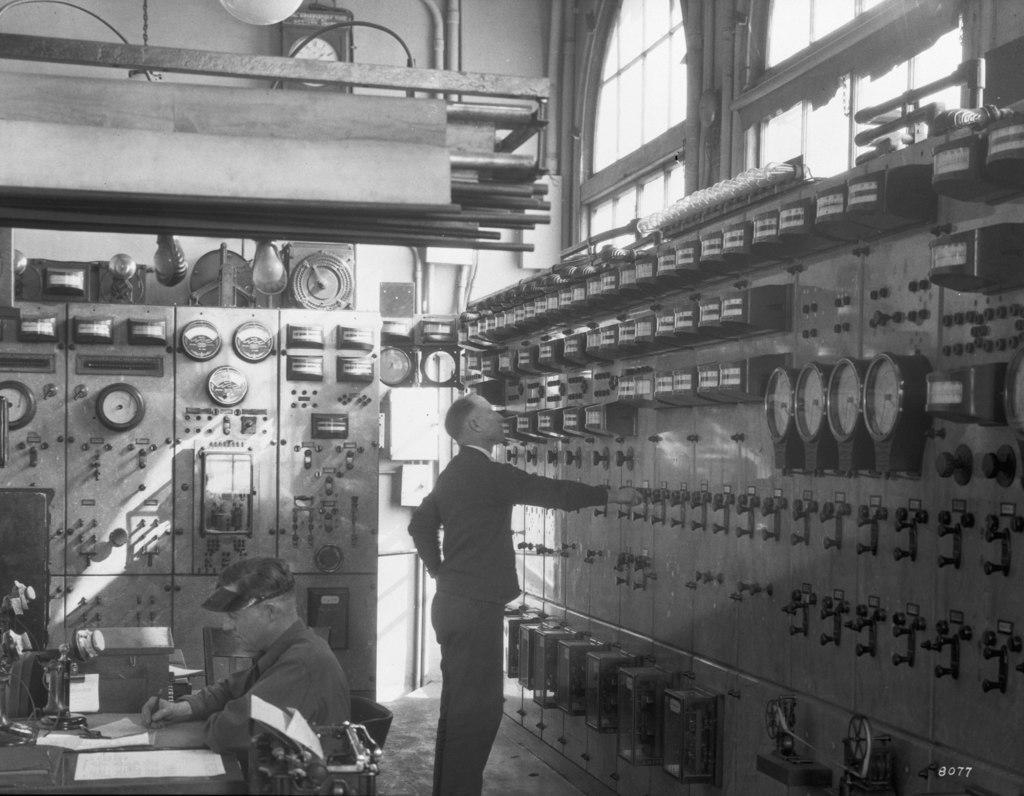In one or two sentences, can you explain what this image depicts? This is a black and white image. In this image I can see few machines. In the middle of the image there is a man standing on the floor and looking at the machine. On the left side there is another person sitting on the chair in front of the table and writing something on a paper. At the top, I can see the wall and window. 